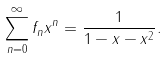<formula> <loc_0><loc_0><loc_500><loc_500>\sum _ { n = 0 } ^ { \infty } f _ { n } x ^ { n } = \frac { 1 } { 1 - x - x ^ { 2 } } .</formula> 